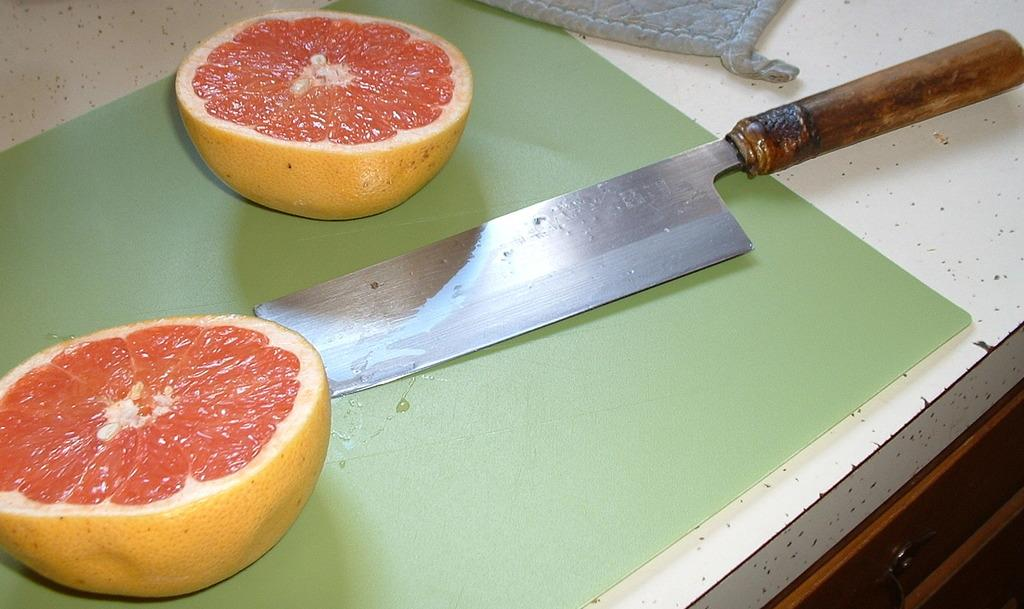What type of food is present in the image? There is a fruit in the image. How is the fruit prepared? The fruit is sliced into two halves. What tool is used for slicing the fruit? There is a knife in the image. Where is the knife placed? The knife is on a cutting board. What is the color of the table where the cutting board is placed? The cutting board is placed on a white table. Can you see any wings on the fruit in the image? There are no wings present on the fruit in the image. What rule is being followed while slicing the fruit in the image? There is no specific rule mentioned or depicted in the image regarding the slicing of the fruit. 